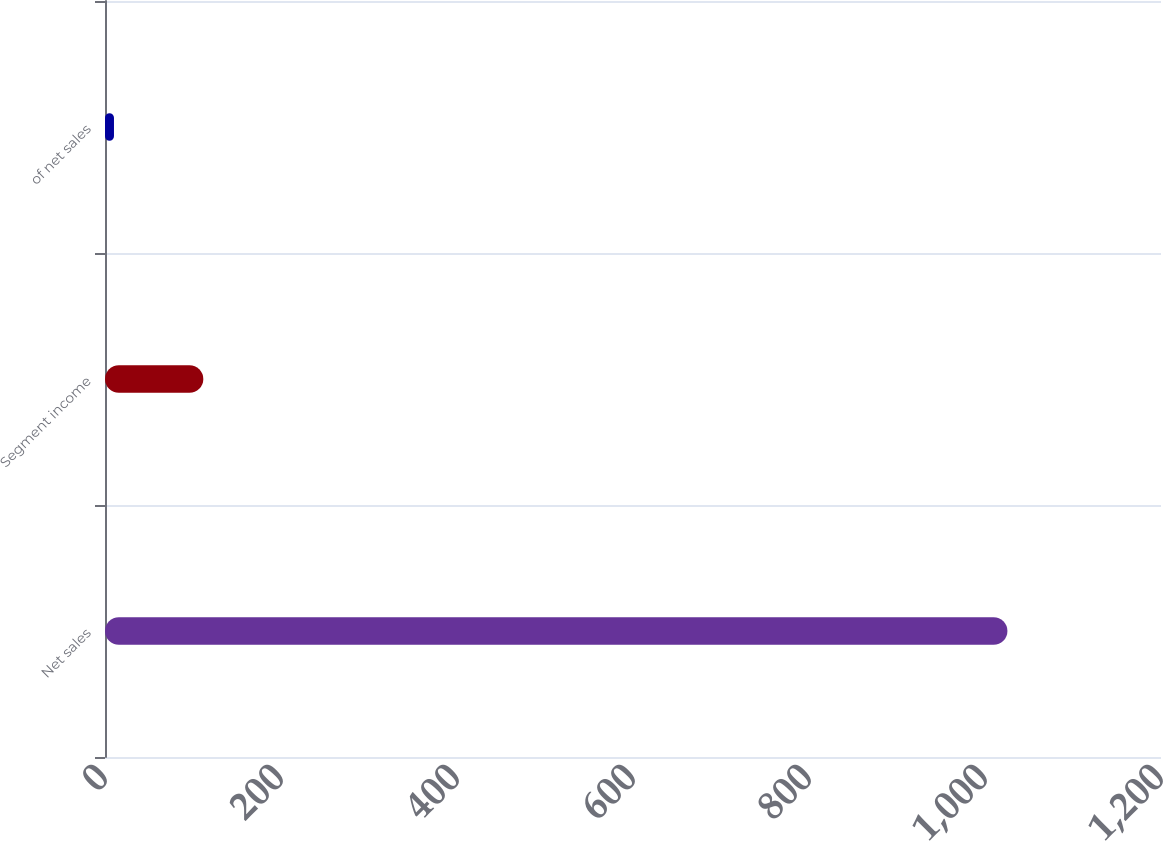Convert chart. <chart><loc_0><loc_0><loc_500><loc_500><bar_chart><fcel>Net sales<fcel>Segment income<fcel>of net sales<nl><fcel>1025.5<fcel>111.73<fcel>10.2<nl></chart> 